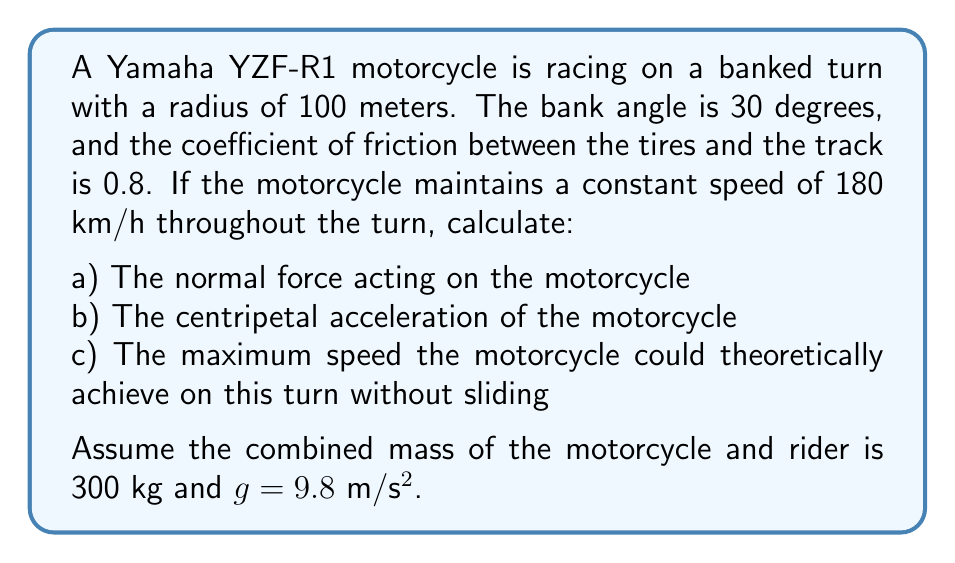Could you help me with this problem? Let's approach this problem step by step:

1) First, we need to convert the speed from km/h to m/s:
   $$ 180 \text{ km/h} = 180 * \frac{1000}{3600} = 50 \text{ m/s} $$

2) The forces acting on the motorcycle are:
   - Weight (mg)
   - Normal force (N)
   - Friction force (f)
   - Centripetal force (mv²/r)

3) For part a), we can find the normal force by resolving forces perpendicular to the banked surface:
   $$ N \cos 30° = mg \cos 30° + \frac{mv^2}{r} \sin 30° $$
   $$ N = m(g \cos 30° + \frac{v^2}{r} \sin 30°) $$
   $$ N = 300(9.8 \cos 30° + \frac{50^2}{100} \sin 30°) = 3897.7 \text{ N} $$

4) For part b), the centripetal acceleration is given by v²/r:
   $$ a_c = \frac{v^2}{r} = \frac{50^2}{100} = 25 \text{ m/s}^2 $$

5) For part c), we need to find the maximum speed before sliding occurs. At this point, the friction force will be at its maximum:
   $$ f_{max} = \mu N $$

   The sum of the friction force and the component of the normal force parallel to the track must equal the centripetal force:
   $$ \mu N + N \sin 30° = \frac{mv_{max}^2}{r} $$

   Substituting N from step 3 and solving for v_max:

   $$ \mu m(g \cos 30° + \frac{v_{max}^2}{r} \sin 30°) + m(g \cos 30° + \frac{v_{max}^2}{r} \sin 30°) \sin 30° = \frac{mv_{max}^2}{r} $$

   This equation can be solved numerically to find v_max ≈ 69.4 m/s or 249.8 km/h.
Answer: a) The normal force acting on the motorcycle is 3897.7 N.
b) The centripetal acceleration of the motorcycle is 25 m/s².
c) The maximum theoretical speed the motorcycle could achieve on this turn without sliding is approximately 249.8 km/h. 